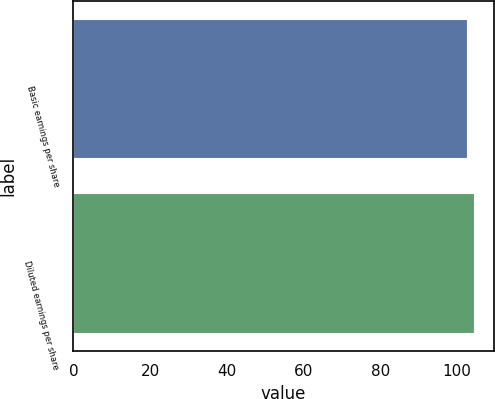<chart> <loc_0><loc_0><loc_500><loc_500><bar_chart><fcel>Basic earnings per share<fcel>Diluted earnings per share<nl><fcel>102.5<fcel>104.3<nl></chart> 